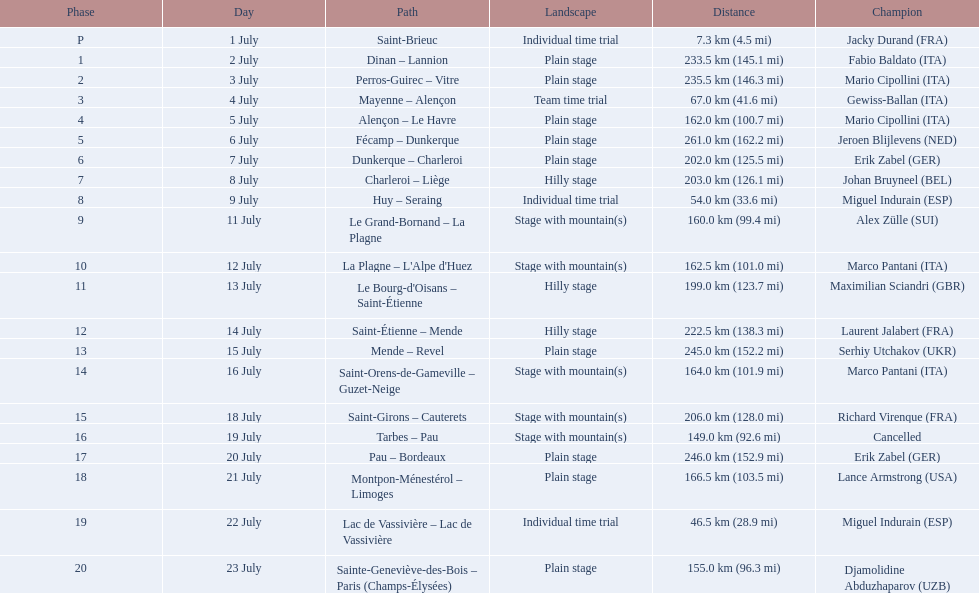What were the dates of the 1995 tour de france? 1 July, 2 July, 3 July, 4 July, 5 July, 6 July, 7 July, 8 July, 9 July, 11 July, 12 July, 13 July, 14 July, 15 July, 16 July, 18 July, 19 July, 20 July, 21 July, 22 July, 23 July. What was the length for july 8th? 203.0 km (126.1 mi). 